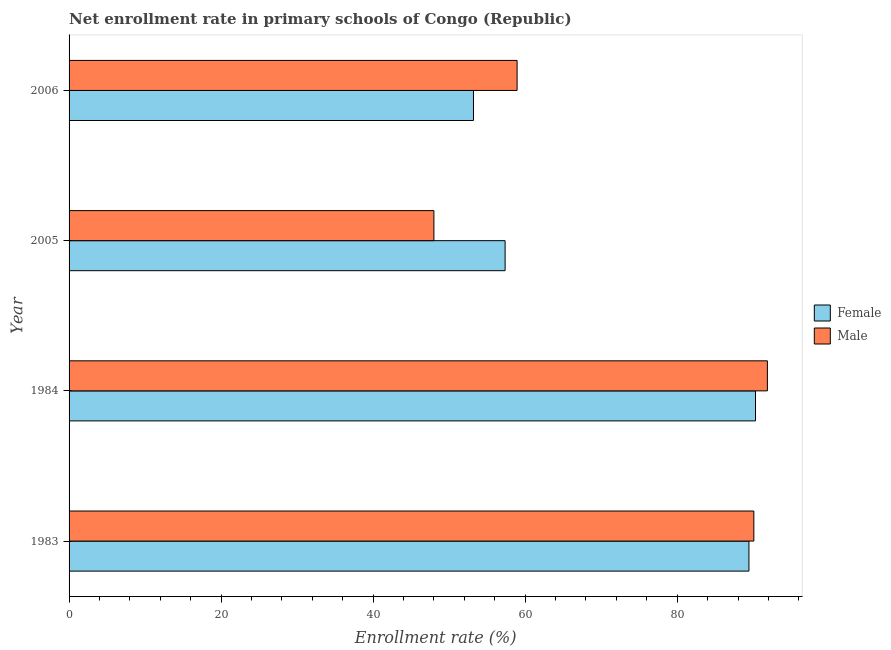How many groups of bars are there?
Your answer should be very brief. 4. Are the number of bars per tick equal to the number of legend labels?
Your answer should be very brief. Yes. Are the number of bars on each tick of the Y-axis equal?
Give a very brief answer. Yes. How many bars are there on the 4th tick from the bottom?
Your answer should be compact. 2. What is the label of the 1st group of bars from the top?
Make the answer very short. 2006. What is the enrollment rate of female students in 1984?
Your answer should be very brief. 90.3. Across all years, what is the maximum enrollment rate of female students?
Ensure brevity in your answer.  90.3. Across all years, what is the minimum enrollment rate of male students?
Keep it short and to the point. 47.99. In which year was the enrollment rate of female students maximum?
Provide a succinct answer. 1984. In which year was the enrollment rate of female students minimum?
Keep it short and to the point. 2006. What is the total enrollment rate of female students in the graph?
Keep it short and to the point. 290.3. What is the difference between the enrollment rate of male students in 1983 and that in 1984?
Keep it short and to the point. -1.78. What is the difference between the enrollment rate of male students in 2005 and the enrollment rate of female students in 2006?
Offer a very short reply. -5.21. What is the average enrollment rate of female students per year?
Ensure brevity in your answer.  72.57. In the year 1983, what is the difference between the enrollment rate of male students and enrollment rate of female students?
Keep it short and to the point. 0.64. What is the ratio of the enrollment rate of female students in 1984 to that in 2005?
Keep it short and to the point. 1.57. Is the difference between the enrollment rate of male students in 1984 and 2006 greater than the difference between the enrollment rate of female students in 1984 and 2006?
Your answer should be compact. No. What is the difference between the highest and the second highest enrollment rate of female students?
Give a very brief answer. 0.86. What is the difference between the highest and the lowest enrollment rate of male students?
Provide a short and direct response. 43.87. What does the 1st bar from the top in 2006 represents?
Your response must be concise. Male. What does the 2nd bar from the bottom in 2005 represents?
Provide a short and direct response. Male. Are all the bars in the graph horizontal?
Keep it short and to the point. Yes. What is the difference between two consecutive major ticks on the X-axis?
Ensure brevity in your answer.  20. Does the graph contain any zero values?
Your response must be concise. No. Does the graph contain grids?
Ensure brevity in your answer.  No. How many legend labels are there?
Provide a succinct answer. 2. How are the legend labels stacked?
Provide a short and direct response. Vertical. What is the title of the graph?
Provide a succinct answer. Net enrollment rate in primary schools of Congo (Republic). Does "Money lenders" appear as one of the legend labels in the graph?
Offer a very short reply. No. What is the label or title of the X-axis?
Provide a succinct answer. Enrollment rate (%). What is the label or title of the Y-axis?
Give a very brief answer. Year. What is the Enrollment rate (%) in Female in 1983?
Keep it short and to the point. 89.44. What is the Enrollment rate (%) of Male in 1983?
Provide a succinct answer. 90.08. What is the Enrollment rate (%) in Female in 1984?
Offer a very short reply. 90.3. What is the Enrollment rate (%) of Male in 1984?
Your answer should be very brief. 91.86. What is the Enrollment rate (%) of Female in 2005?
Ensure brevity in your answer.  57.36. What is the Enrollment rate (%) in Male in 2005?
Ensure brevity in your answer.  47.99. What is the Enrollment rate (%) of Female in 2006?
Keep it short and to the point. 53.2. What is the Enrollment rate (%) in Male in 2006?
Provide a short and direct response. 58.94. Across all years, what is the maximum Enrollment rate (%) of Female?
Make the answer very short. 90.3. Across all years, what is the maximum Enrollment rate (%) in Male?
Your response must be concise. 91.86. Across all years, what is the minimum Enrollment rate (%) in Female?
Ensure brevity in your answer.  53.2. Across all years, what is the minimum Enrollment rate (%) of Male?
Your answer should be compact. 47.99. What is the total Enrollment rate (%) in Female in the graph?
Your response must be concise. 290.3. What is the total Enrollment rate (%) of Male in the graph?
Provide a succinct answer. 288.88. What is the difference between the Enrollment rate (%) of Female in 1983 and that in 1984?
Your answer should be very brief. -0.86. What is the difference between the Enrollment rate (%) in Male in 1983 and that in 1984?
Offer a very short reply. -1.78. What is the difference between the Enrollment rate (%) of Female in 1983 and that in 2005?
Your answer should be very brief. 32.08. What is the difference between the Enrollment rate (%) in Male in 1983 and that in 2005?
Your response must be concise. 42.09. What is the difference between the Enrollment rate (%) in Female in 1983 and that in 2006?
Your response must be concise. 36.24. What is the difference between the Enrollment rate (%) of Male in 1983 and that in 2006?
Your response must be concise. 31.14. What is the difference between the Enrollment rate (%) of Female in 1984 and that in 2005?
Offer a very short reply. 32.94. What is the difference between the Enrollment rate (%) in Male in 1984 and that in 2005?
Your answer should be compact. 43.87. What is the difference between the Enrollment rate (%) in Female in 1984 and that in 2006?
Give a very brief answer. 37.1. What is the difference between the Enrollment rate (%) in Male in 1984 and that in 2006?
Ensure brevity in your answer.  32.93. What is the difference between the Enrollment rate (%) in Female in 2005 and that in 2006?
Provide a short and direct response. 4.16. What is the difference between the Enrollment rate (%) in Male in 2005 and that in 2006?
Offer a terse response. -10.94. What is the difference between the Enrollment rate (%) in Female in 1983 and the Enrollment rate (%) in Male in 1984?
Ensure brevity in your answer.  -2.43. What is the difference between the Enrollment rate (%) in Female in 1983 and the Enrollment rate (%) in Male in 2005?
Make the answer very short. 41.44. What is the difference between the Enrollment rate (%) in Female in 1983 and the Enrollment rate (%) in Male in 2006?
Offer a terse response. 30.5. What is the difference between the Enrollment rate (%) in Female in 1984 and the Enrollment rate (%) in Male in 2005?
Make the answer very short. 42.31. What is the difference between the Enrollment rate (%) in Female in 1984 and the Enrollment rate (%) in Male in 2006?
Offer a terse response. 31.36. What is the difference between the Enrollment rate (%) in Female in 2005 and the Enrollment rate (%) in Male in 2006?
Make the answer very short. -1.58. What is the average Enrollment rate (%) of Female per year?
Offer a terse response. 72.57. What is the average Enrollment rate (%) of Male per year?
Provide a succinct answer. 72.22. In the year 1983, what is the difference between the Enrollment rate (%) in Female and Enrollment rate (%) in Male?
Your answer should be compact. -0.64. In the year 1984, what is the difference between the Enrollment rate (%) in Female and Enrollment rate (%) in Male?
Your answer should be compact. -1.56. In the year 2005, what is the difference between the Enrollment rate (%) of Female and Enrollment rate (%) of Male?
Provide a succinct answer. 9.37. In the year 2006, what is the difference between the Enrollment rate (%) of Female and Enrollment rate (%) of Male?
Your answer should be very brief. -5.74. What is the ratio of the Enrollment rate (%) in Male in 1983 to that in 1984?
Your answer should be compact. 0.98. What is the ratio of the Enrollment rate (%) of Female in 1983 to that in 2005?
Make the answer very short. 1.56. What is the ratio of the Enrollment rate (%) of Male in 1983 to that in 2005?
Give a very brief answer. 1.88. What is the ratio of the Enrollment rate (%) in Female in 1983 to that in 2006?
Give a very brief answer. 1.68. What is the ratio of the Enrollment rate (%) of Male in 1983 to that in 2006?
Provide a short and direct response. 1.53. What is the ratio of the Enrollment rate (%) of Female in 1984 to that in 2005?
Offer a terse response. 1.57. What is the ratio of the Enrollment rate (%) of Male in 1984 to that in 2005?
Make the answer very short. 1.91. What is the ratio of the Enrollment rate (%) in Female in 1984 to that in 2006?
Provide a succinct answer. 1.7. What is the ratio of the Enrollment rate (%) of Male in 1984 to that in 2006?
Provide a succinct answer. 1.56. What is the ratio of the Enrollment rate (%) of Female in 2005 to that in 2006?
Ensure brevity in your answer.  1.08. What is the ratio of the Enrollment rate (%) of Male in 2005 to that in 2006?
Your answer should be compact. 0.81. What is the difference between the highest and the second highest Enrollment rate (%) of Female?
Your answer should be very brief. 0.86. What is the difference between the highest and the second highest Enrollment rate (%) of Male?
Offer a terse response. 1.78. What is the difference between the highest and the lowest Enrollment rate (%) in Female?
Offer a terse response. 37.1. What is the difference between the highest and the lowest Enrollment rate (%) in Male?
Your answer should be compact. 43.87. 